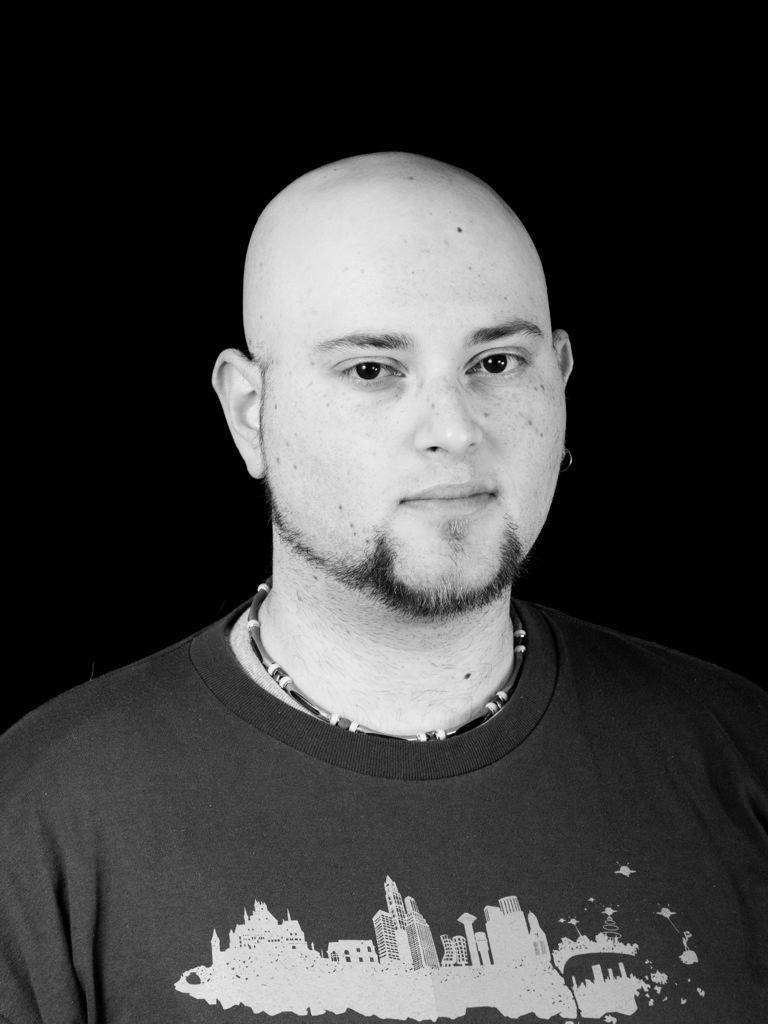What is the color scheme of the image? The image is black and white. Can you describe the main subject of the image? There is a man in the picture. What can be seen in the background of the image? The background of the image is dark. What is the man's desire in the image? There is no information about the man's desires in the image, as it is a black and white photograph. How does the image relate to the concept of fiction? The image is a photograph, not a work of fiction. 